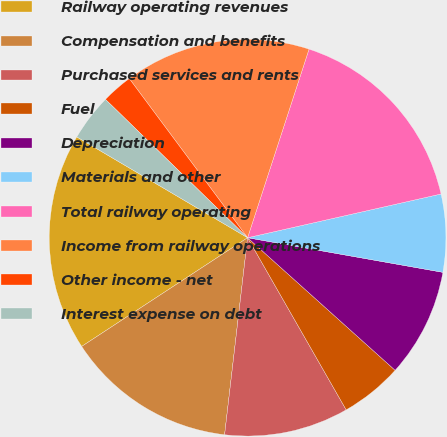Convert chart. <chart><loc_0><loc_0><loc_500><loc_500><pie_chart><fcel>Railway operating revenues<fcel>Compensation and benefits<fcel>Purchased services and rents<fcel>Fuel<fcel>Depreciation<fcel>Materials and other<fcel>Total railway operating<fcel>Income from railway operations<fcel>Other income - net<fcel>Interest expense on debt<nl><fcel>17.72%<fcel>13.92%<fcel>10.13%<fcel>5.07%<fcel>8.86%<fcel>6.33%<fcel>16.45%<fcel>15.19%<fcel>2.54%<fcel>3.8%<nl></chart> 